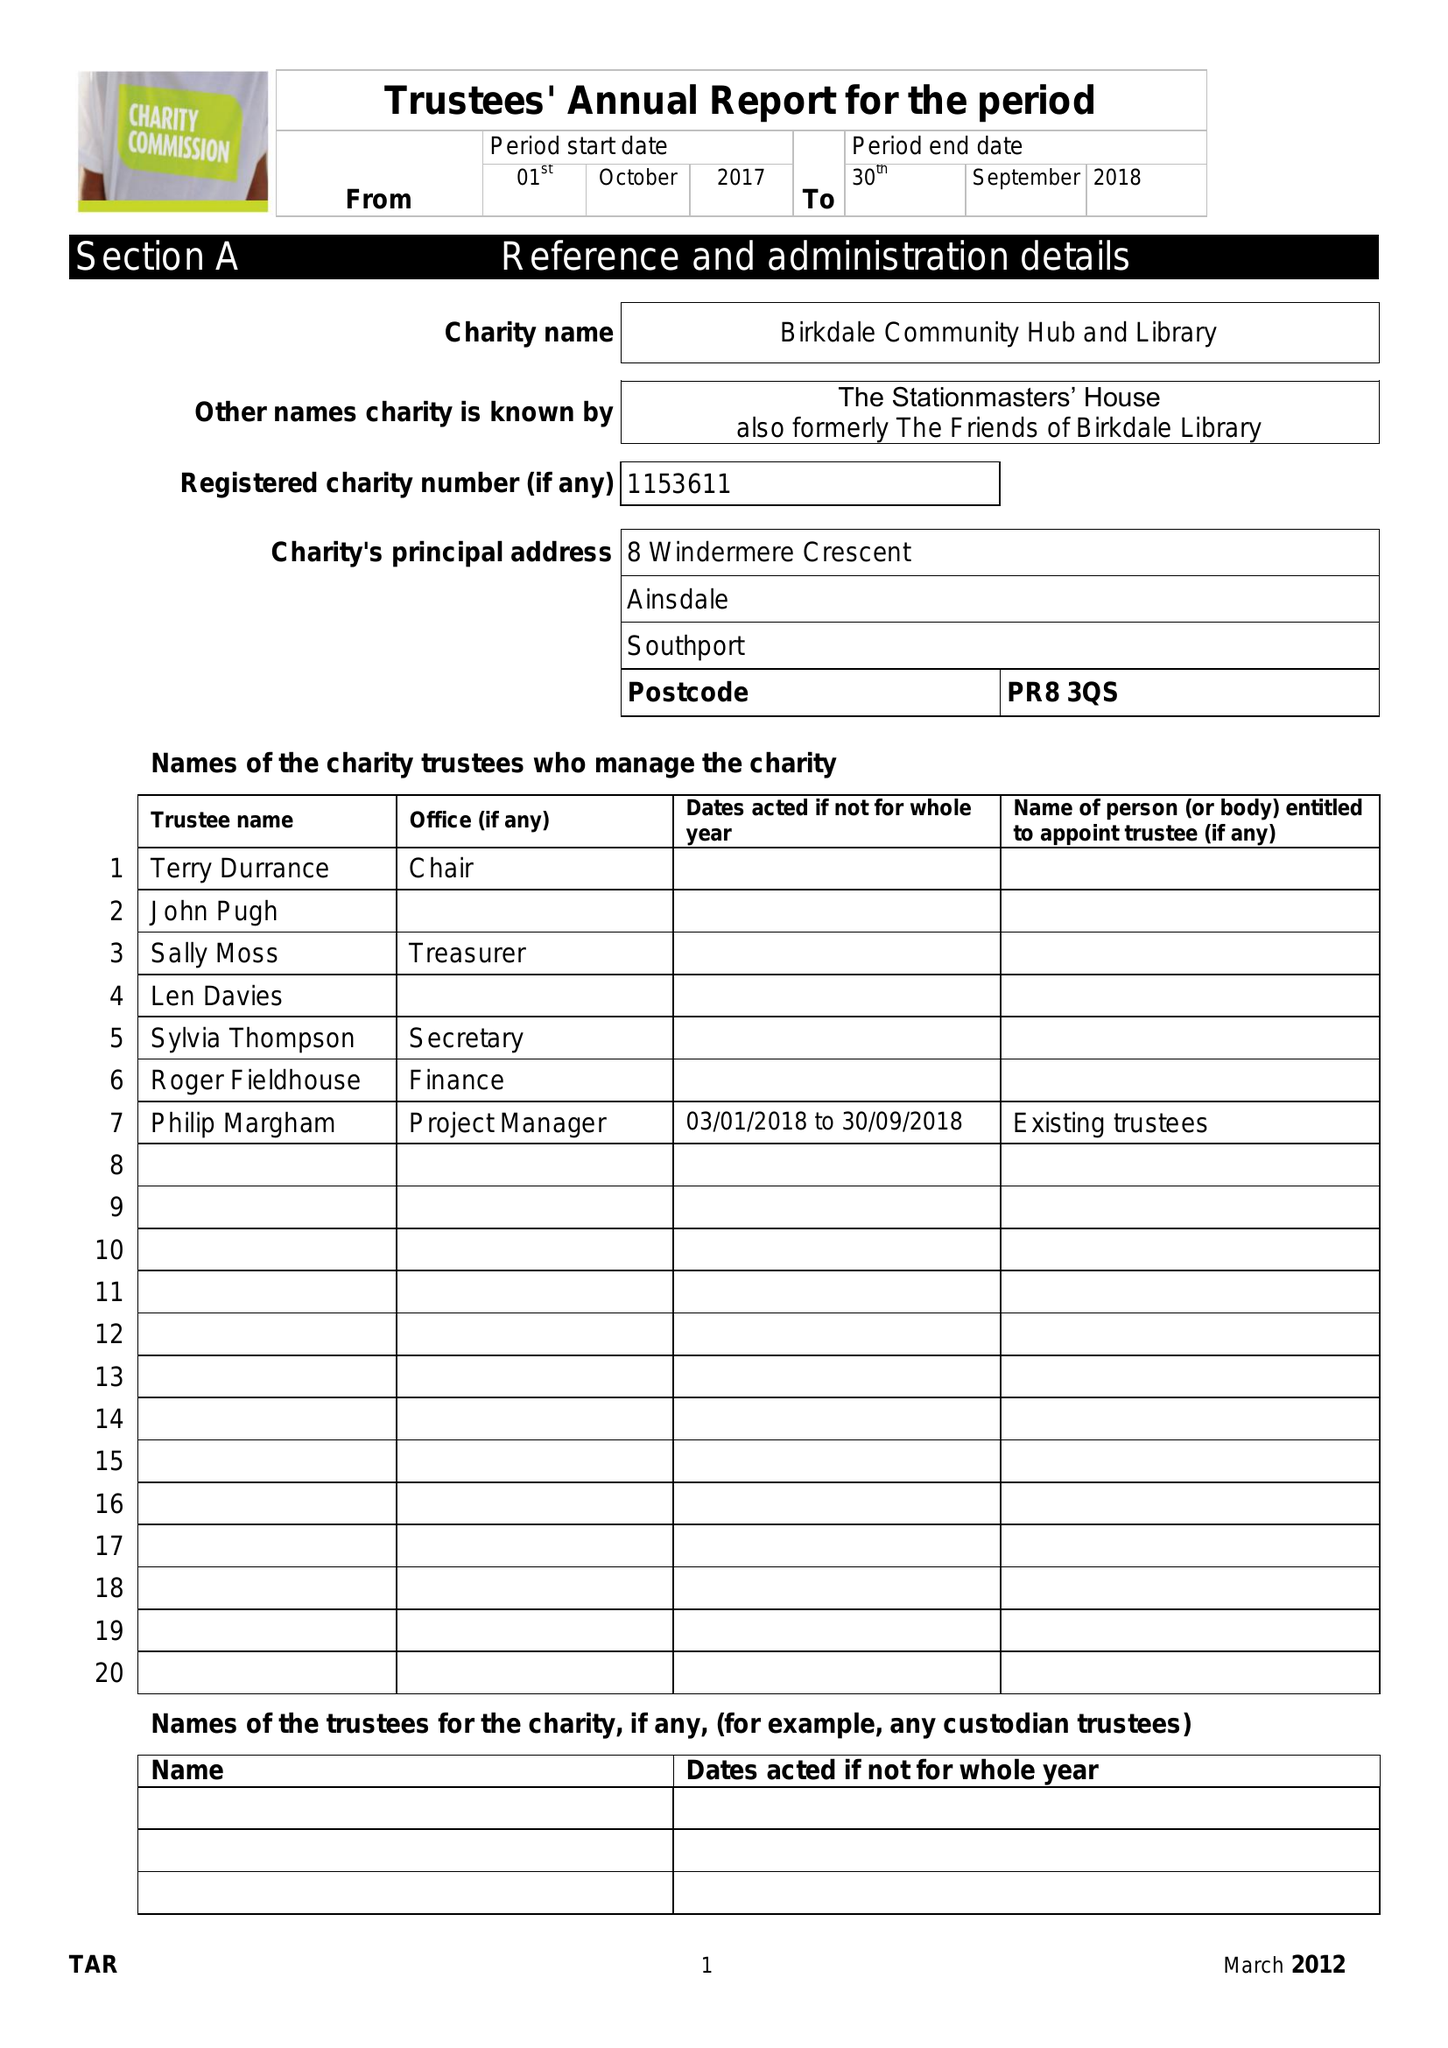What is the value for the report_date?
Answer the question using a single word or phrase. 2018-09-30 